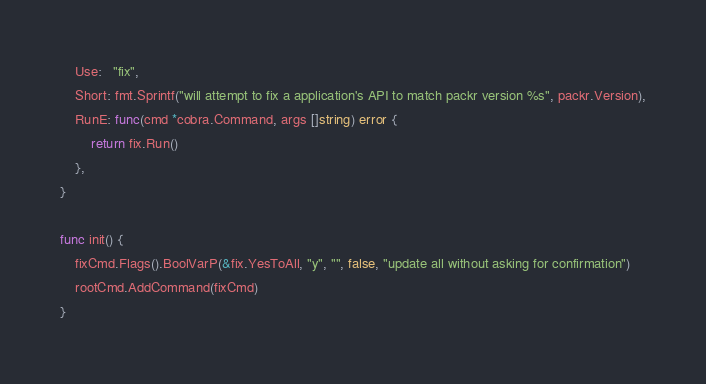<code> <loc_0><loc_0><loc_500><loc_500><_Go_>	Use:   "fix",
	Short: fmt.Sprintf("will attempt to fix a application's API to match packr version %s", packr.Version),
	RunE: func(cmd *cobra.Command, args []string) error {
		return fix.Run()
	},
}

func init() {
	fixCmd.Flags().BoolVarP(&fix.YesToAll, "y", "", false, "update all without asking for confirmation")
	rootCmd.AddCommand(fixCmd)
}
</code> 